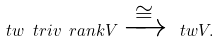Convert formula to latex. <formula><loc_0><loc_0><loc_500><loc_500>\ t w { \ t r i v { \ r a n k V } } \xrightarrow { \, \cong \, } \ t w V .</formula> 